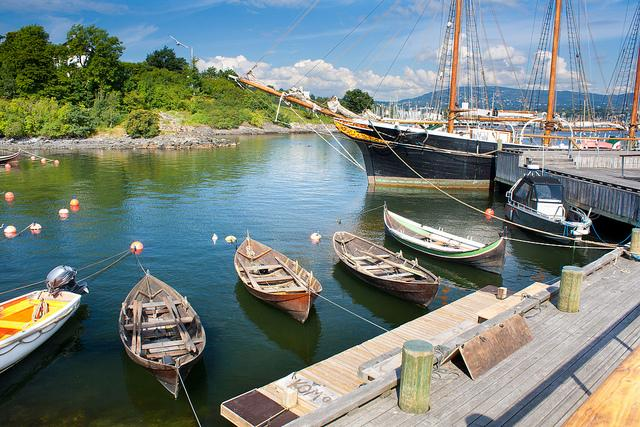What is the color of the sail boat?

Choices:
A) red
B) orange
C) white
D) black black 